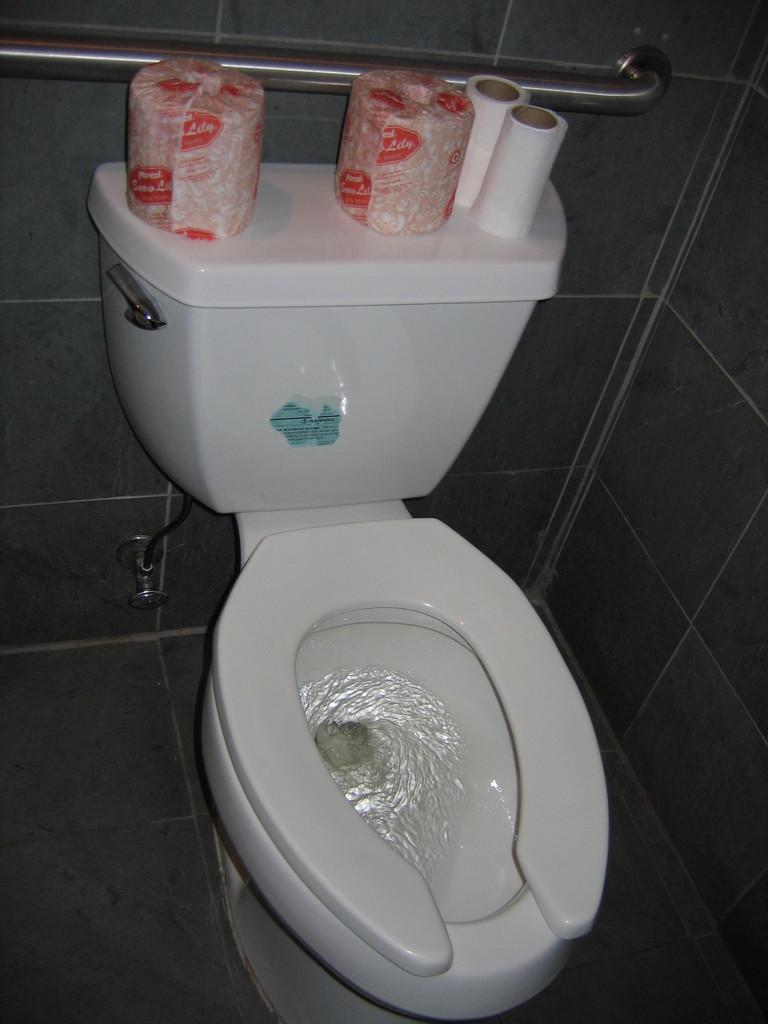What is the main object in the image? There is a toilet in the image. What can be seen near the toilet? There are tissue papers in the image. What is the purpose of the stand in the image? The stand is likely for holding the tissue papers or other bathroom essentials. What is the source of water in the image? There is a tap in the image. What is the background of the image made of? There is a wall in the image. What type of nail can be seen on the wall in the image? There are no nails visible on the wall in the image. What kind of fowl is present in the image? There are no fowl present in the image; it is a bathroom setting. 